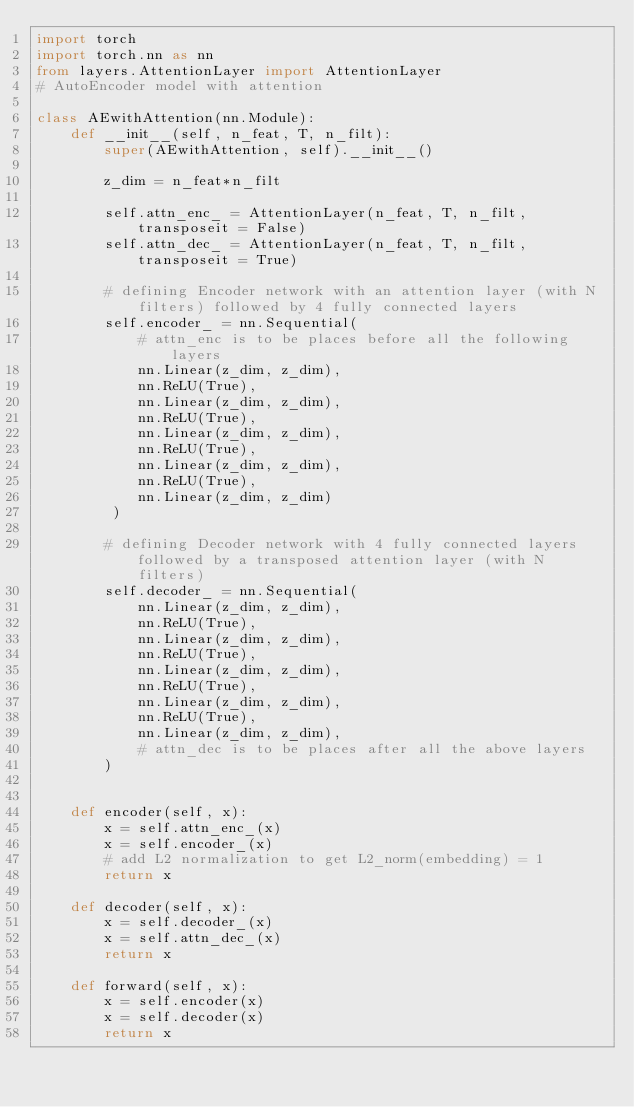Convert code to text. <code><loc_0><loc_0><loc_500><loc_500><_Python_>import torch
import torch.nn as nn
from layers.AttentionLayer import AttentionLayer
# AutoEncoder model with attention 

class AEwithAttention(nn.Module):
    def __init__(self, n_feat, T, n_filt):
        super(AEwithAttention, self).__init__()
        
        z_dim = n_feat*n_filt
        
        self.attn_enc_ = AttentionLayer(n_feat, T, n_filt, transposeit = False)
        self.attn_dec_ = AttentionLayer(n_feat, T, n_filt, transposeit = True)
        
        # defining Encoder network with an attention layer (with N filters) followed by 4 fully connected layers
        self.encoder_ = nn.Sequential(
            # attn_enc is to be places before all the following layers
            nn.Linear(z_dim, z_dim),
            nn.ReLU(True),
            nn.Linear(z_dim, z_dim),
            nn.ReLU(True),
            nn.Linear(z_dim, z_dim),
            nn.ReLU(True),
            nn.Linear(z_dim, z_dim),
            nn.ReLU(True),
            nn.Linear(z_dim, z_dim)
         )
        
        # defining Decoder network with 4 fully connected layers followed by a transposed attention layer (with N filters)
        self.decoder_ = nn.Sequential(
            nn.Linear(z_dim, z_dim),
            nn.ReLU(True),
            nn.Linear(z_dim, z_dim),
            nn.ReLU(True),
            nn.Linear(z_dim, z_dim),
            nn.ReLU(True),
            nn.Linear(z_dim, z_dim),
            nn.ReLU(True),
            nn.Linear(z_dim, z_dim),
            # attn_dec is to be places after all the above layers
        )
         

    def encoder(self, x):
        x = self.attn_enc_(x)
        x = self.encoder_(x)
        # add L2 normalization to get L2_norm(embedding) = 1
        return x
    
    def decoder(self, x):
        x = self.decoder_(x)
        x = self.attn_dec_(x)
        return x
    
    def forward(self, x):
        x = self.encoder(x)
        x = self.decoder(x)
        return x
</code> 